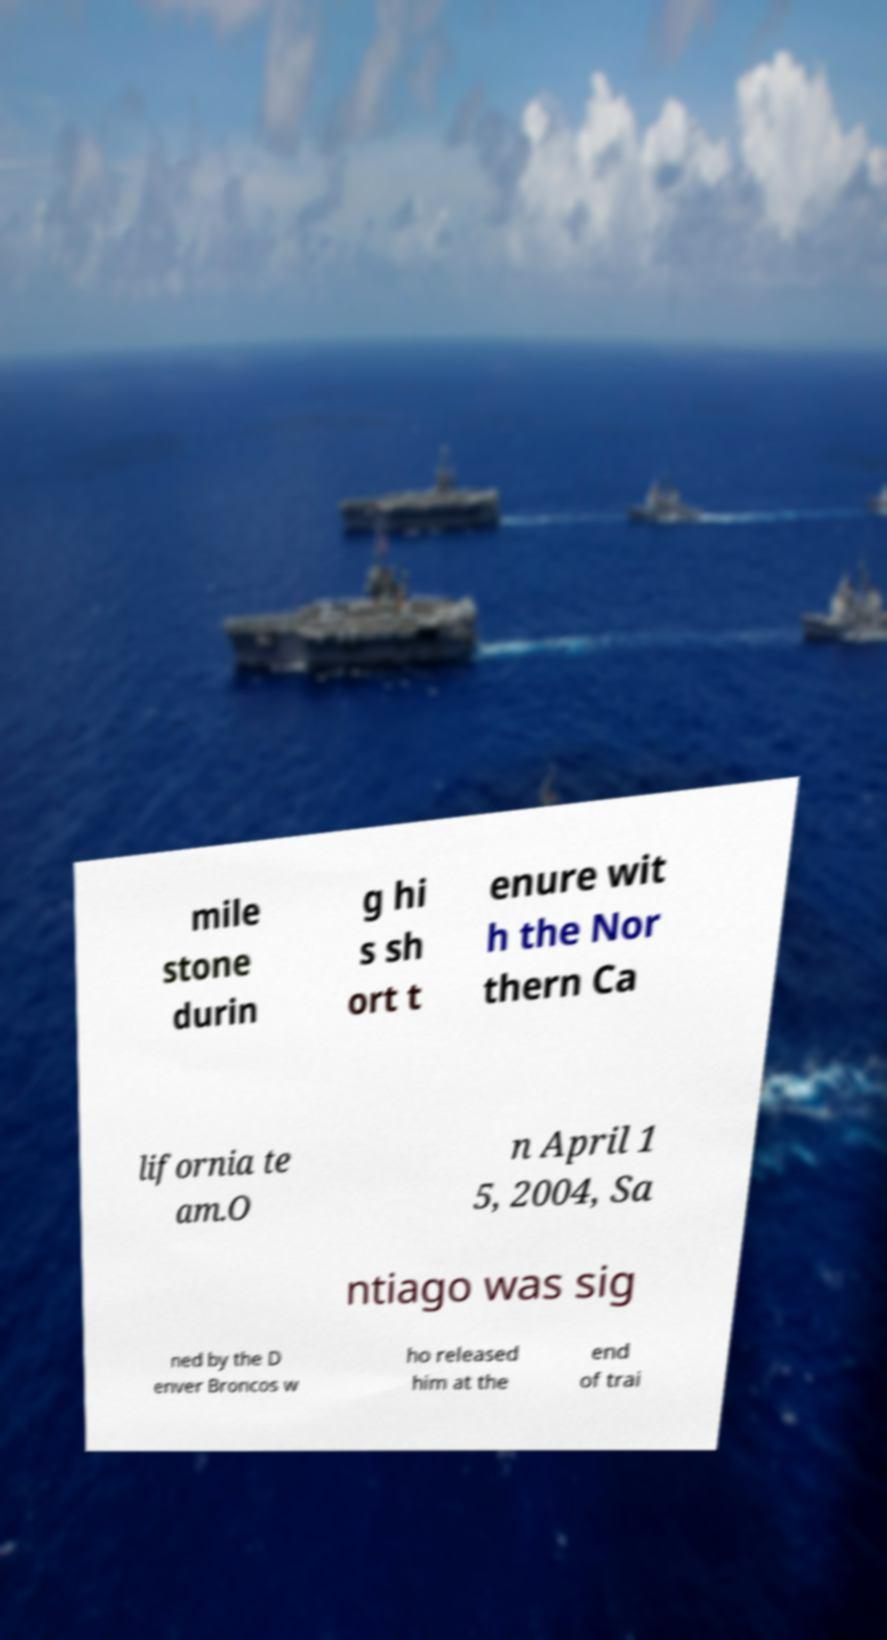I need the written content from this picture converted into text. Can you do that? mile stone durin g hi s sh ort t enure wit h the Nor thern Ca lifornia te am.O n April 1 5, 2004, Sa ntiago was sig ned by the D enver Broncos w ho released him at the end of trai 